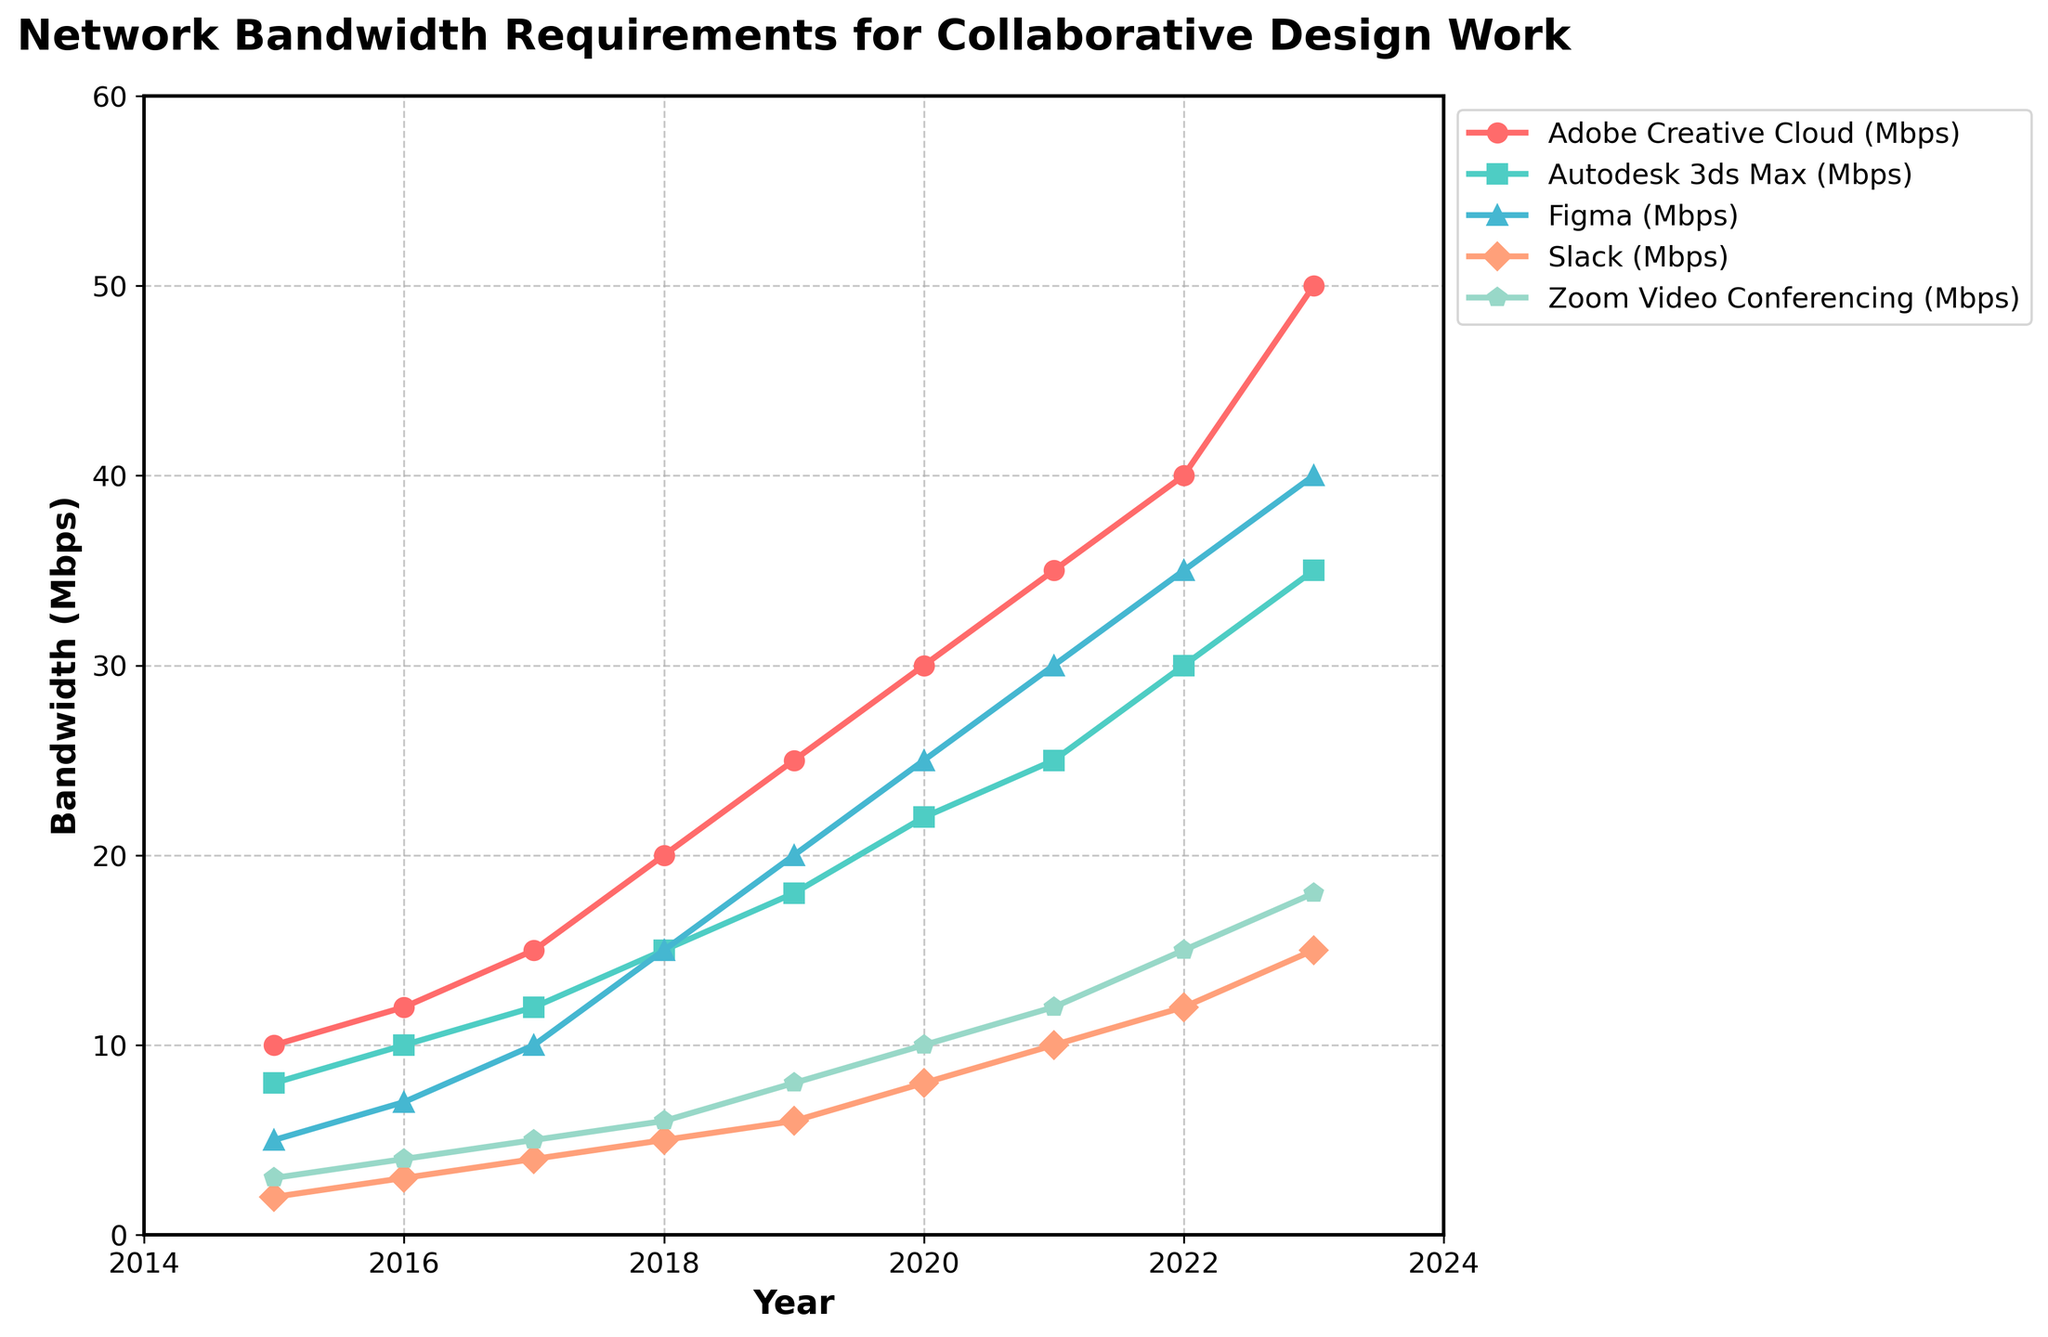What is the trend of bandwidth requirements for Adobe Creative Cloud from 2015 to 2023? To determine the trend, observe the data points for Adobe Creative Cloud from 2015 (10 Mbps) to 2023 (50 Mbps). Notice the consistent increase over the years. This shows a clear, steadily rising trend.
Answer: Steadily rising Which software had the steepest increase in bandwidth requirements between 2015 and 2023? Compare the change in bandwidth requirements for each software between 2015 and 2023. Adobe Creative Cloud increased from 10 Mbps (2015) to 50 Mbps (2023), which is an increase of 40 Mbps, the highest among all.
Answer: Adobe Creative Cloud In 2020, how much more bandwidth did Autodesk 3ds Max require compared to Slack? In 2020, Autodesk 3ds Max required 22 Mbps, and Slack required 8 Mbps. The difference is 22 - 8 = 14 Mbps.
Answer: 14 Mbps Which software required the least bandwidth in 2015? By observing the data points for 2015, we see that Slack required 2 Mbps, which is the lowest bandwidth requirement among the listed software for that year.
Answer: Slack Between which consecutive years did Figma see the most significant bandwidth requirement increase? Observe the data points for Figma for each year and calculate the year-over-year differences. The most significant increase was between 2018 (15 Mbps) and 2019 (20 Mbps), a difference of 5 Mbps.
Answer: 2018 to 2019 By how much did the bandwidth requirements for Zoom Video Conferencing increase from 2019 to 2020? In 2019, Zoom Video Conferencing required 8 Mbps, and in 2020, it required 10 Mbps. The increase is 10 - 8 = 2 Mbps.
Answer: 2 Mbps Which software had the highest bandwidth requirement in 2022? By looking at the data points for 2022, Adobe Creative Cloud had the highest requirement with 40 Mbps.
Answer: Adobe Creative Cloud What is the average bandwidth requirement for Slack from 2015 to 2023? Add up the bandwidth requirements for Slack from 2015 to 2023 (2, 3, 4, 5, 6, 8, 10, 12, 15) which sums to 65. Then divide by 9 years: 65/9 ≈ 7.22 Mbps.
Answer: 7.22 Mbps How does the bandwidth requirement of Figma in 2017 compare to Zoom Video Conferencing in 2023? In 2017, Figma required 10 Mbps, and in 2023, Zoom Video Conferencing required 18 Mbps. Therefore, Figma in 2017 required less bandwidth than Zoom Video Conferencing in 2023.
Answer: Figma required less Which software shows the most variability in bandwidth requirement increases over the years? By observing each software’s year-over-year changes, Zoom Video Conferencing shows varied increases each year compared to others. This variability indicates inconsistent change rates.
Answer: Zoom Video Conferencing 